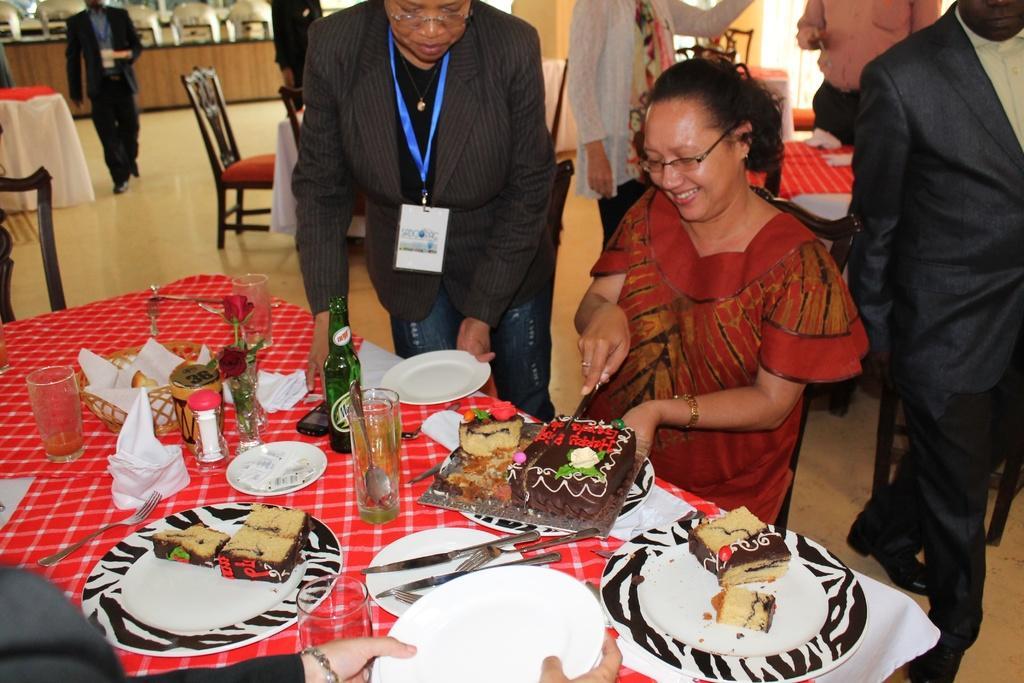How would you summarize this image in a sentence or two? In this image there are group of person's a person wearing red color dress cutting a cake and a person who is standing holding a plate and there are flowers,bottle,glasses,plates,spoons on the table and at the left side of the image there is a person walking. 